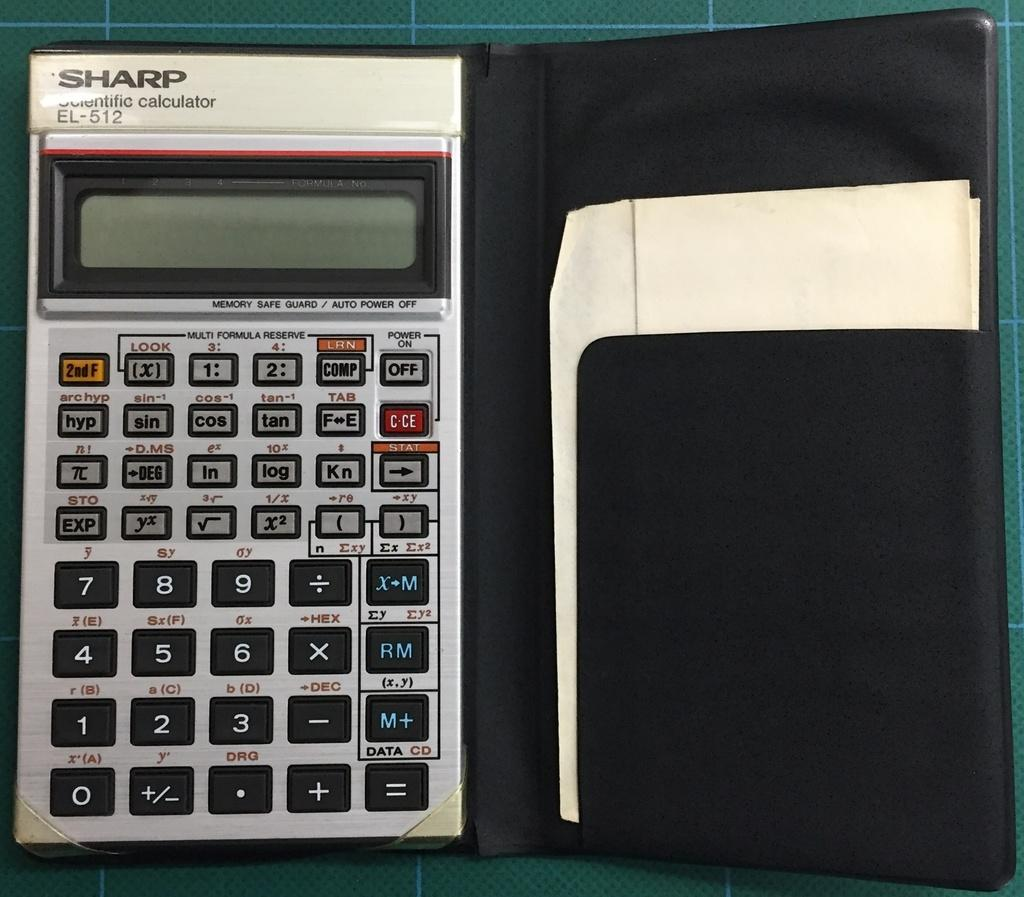<image>
Summarize the visual content of the image. A Sharp electronic calculator El-512 inside a black case with paper beside 